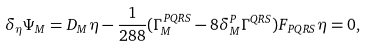Convert formula to latex. <formula><loc_0><loc_0><loc_500><loc_500>\delta _ { \eta } \Psi _ { M } = D _ { M } \eta - \frac { 1 } { 2 8 8 } ( \Gamma _ { M } ^ { P Q R S } - 8 \delta ^ { P } _ { M } \Gamma ^ { Q R S } ) F _ { P Q R S } \eta = 0 ,</formula> 